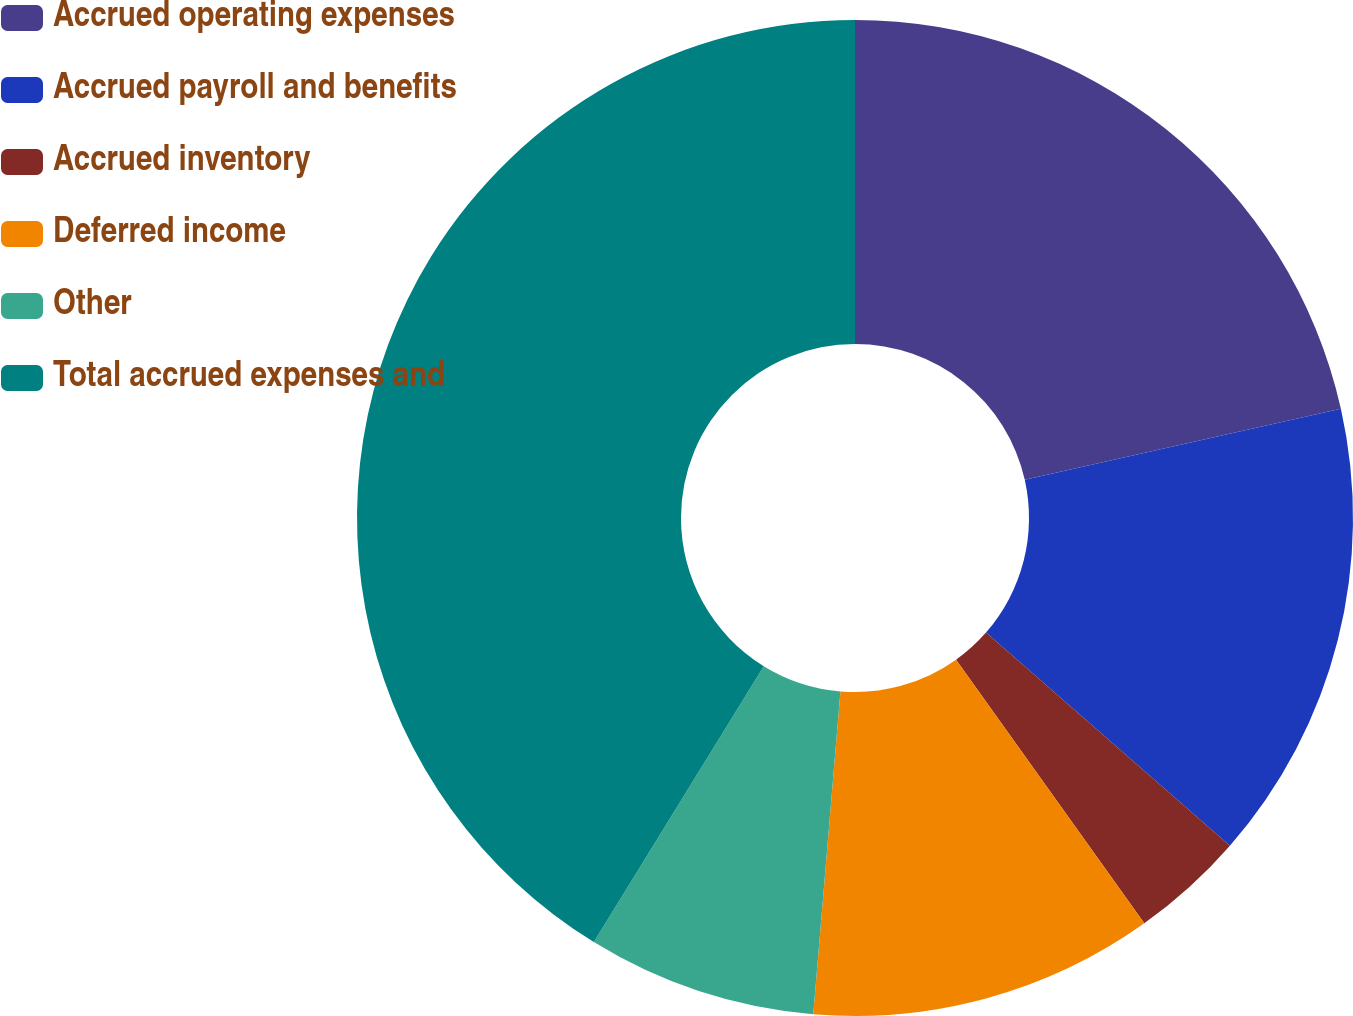Convert chart. <chart><loc_0><loc_0><loc_500><loc_500><pie_chart><fcel>Accrued operating expenses<fcel>Accrued payroll and benefits<fcel>Accrued inventory<fcel>Deferred income<fcel>Other<fcel>Total accrued expenses and<nl><fcel>21.48%<fcel>14.95%<fcel>3.7%<fcel>11.2%<fcel>7.45%<fcel>41.21%<nl></chart> 